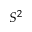Convert formula to latex. <formula><loc_0><loc_0><loc_500><loc_500>S ^ { 2 }</formula> 